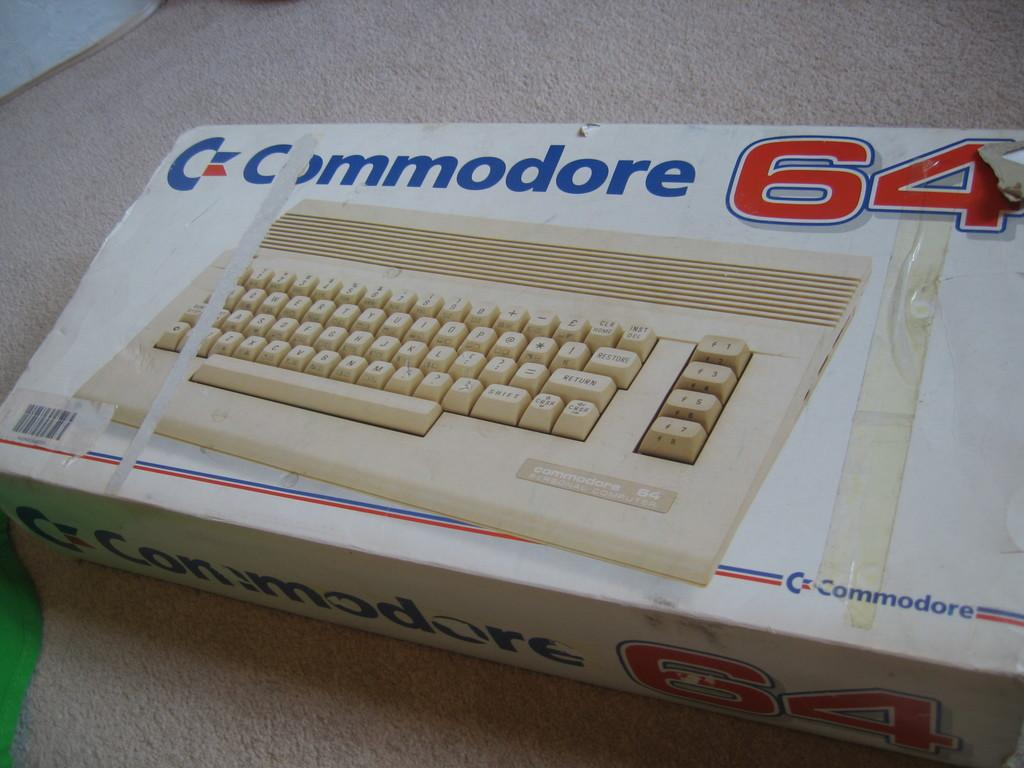<image>
Give a short and clear explanation of the subsequent image. The box contains a keyboard from Commodore 64. 